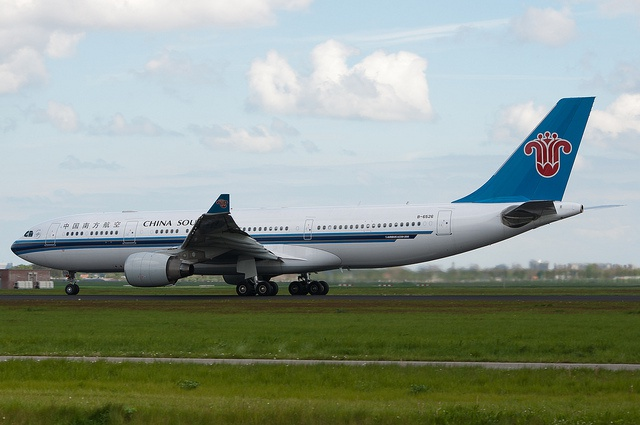Describe the objects in this image and their specific colors. I can see a airplane in white, black, lightgray, gray, and darkgray tones in this image. 